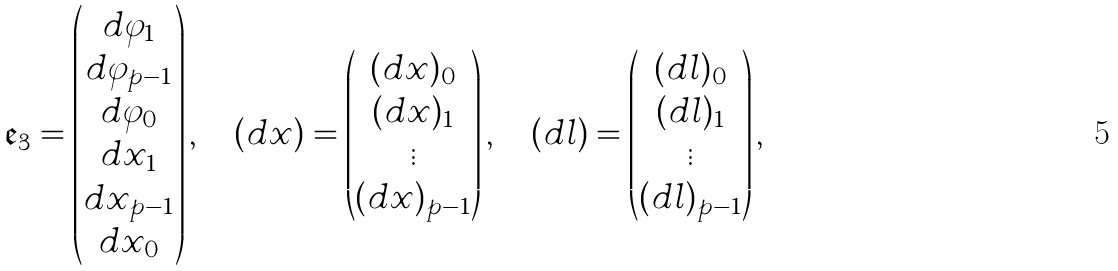<formula> <loc_0><loc_0><loc_500><loc_500>\mathfrak { e } _ { 3 } = \begin{pmatrix} { d \varphi _ { 1 } } \\ { d \varphi _ { p - 1 } } \\ { d \varphi _ { 0 } } \\ { d x _ { 1 } } \\ { d x _ { p - 1 } } \\ { d x _ { 0 } } \end{pmatrix} , \quad ( d x ) = \begin{pmatrix} { ( d x ) _ { 0 } } \\ { ( d x ) _ { 1 } } \\ \vdots \\ { ( d x ) _ { p - 1 } } \end{pmatrix} , \quad ( d l ) = \begin{pmatrix} { ( d l ) _ { 0 } } \\ { ( d l ) _ { 1 } } \\ \vdots \\ { ( d l ) _ { p - 1 } } \end{pmatrix} ,</formula> 